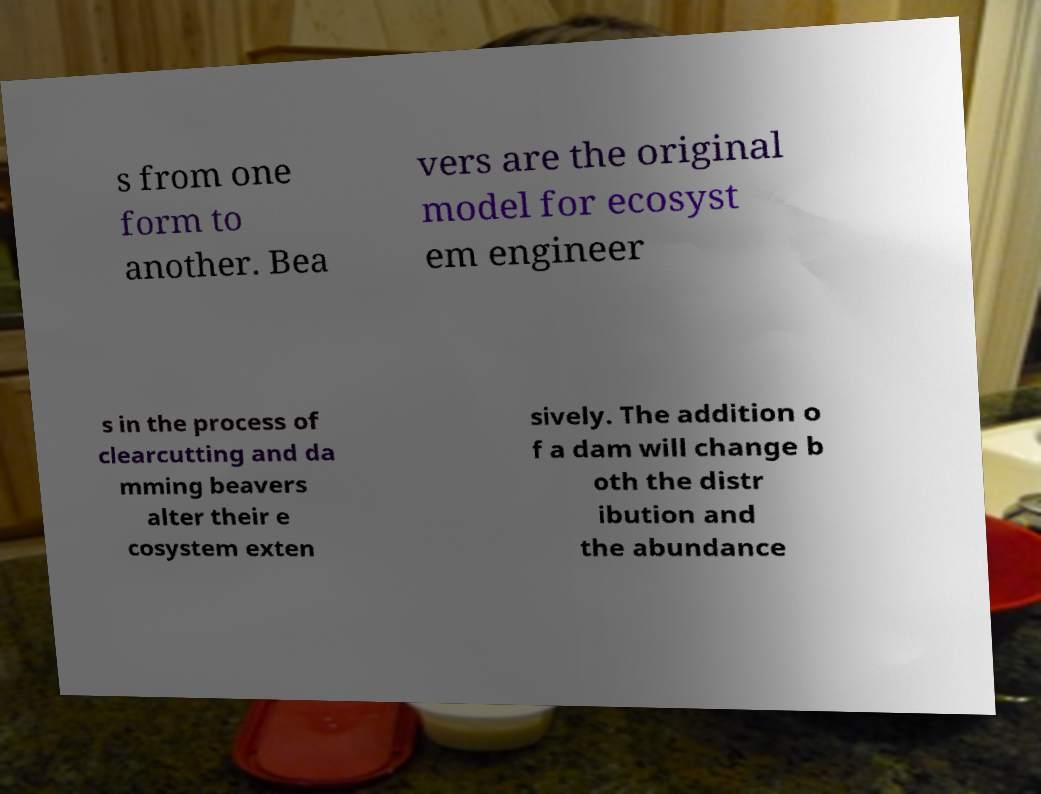Could you extract and type out the text from this image? s from one form to another. Bea vers are the original model for ecosyst em engineer s in the process of clearcutting and da mming beavers alter their e cosystem exten sively. The addition o f a dam will change b oth the distr ibution and the abundance 